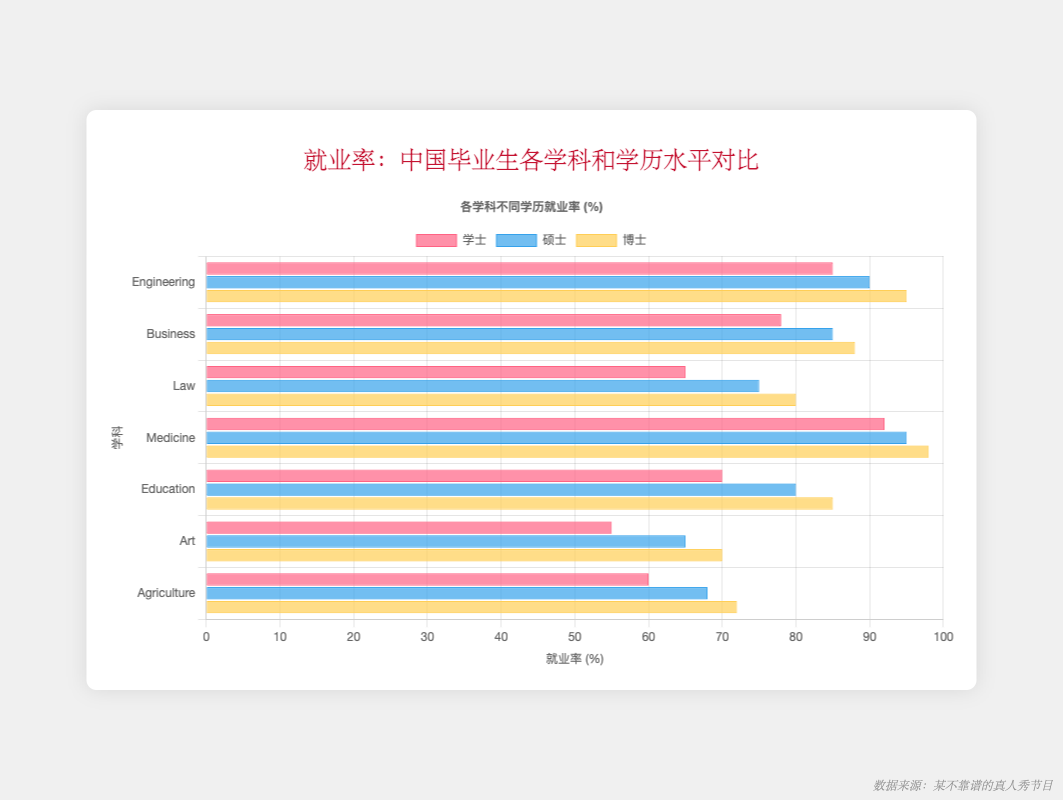What is the employment rate difference between PhD and Bachelor's degree holders in Engineering? To find the difference, look at the bar heights for Engineering for both PhD and Bachelor's education levels. For Engineering, the PhD employment rate is 95% and the Bachelor's rate is 85%. The difference is 95% - 85% = 10%.
Answer: 10% Which field has the highest employment rate at the PhD level? Identify the tallest bar within the PhD cluster across all fields. The field with the highest bar is Medicine with an employment rate of 98%.
Answer: Medicine Are the employment rates for Business graduates higher at the Master's level than at the Bachelor's level? Compare the heights of the bars labeled "Business" within the Bachelor's and Master's groups. The Master's bar is taller, indicating higher employment rates. Bachelor's for Business is 78% and Master's is 85%.
Answer: Yes How do the employment rates in Art differ between Bachelor's and Master's levels? Look at the bar heights for Art in both Bachelor and Master clusters. Bachelor's for Art is 55% and Master's is 65%. The difference is 65% - 55% = 10%.
Answer: 10% Which education level shows the most significant increase in employment rates for Law graduates? For Law, compare the differences between Bachelor's, Master's, and PhD employment rates. Bachelor's is 65%, Master's is 75%, and PhD is 80%. The most significant increase is from Bachelor to Master's: 75% - 65% = 10%.
Answer: Master's What is the combined employment rate of PhD graduates in Agriculture and Education fields? Add the employment rates for Agriculture and Education at the PhD level. Agriculture is 72% and Education is 85%. The combined rate is 72% + 85% = 157%.
Answer: 157% Is the employment rate for Medicine consistently the highest across all education levels? Compare the bar heights for Medicine across Bachelor's, Master's, and PhD levels with other fields. Medicine has consistently higher employment rates: Bachelor's is 92%, Master's is 95%, and PhD is 98%.
Answer: Yes Which color represents the Master's degree employment rates in the chart? Identify the color used for the Master's degree in the chart. Master's degree bars are colored blue.
Answer: Blue How much lower is the employment rate for Law graduates at the Bachelor's level compared to Medicine graduates at the same level? Compare the employment rates of Law and Medicine at the Bachelor's level. Law is 65% and Medicine is 92%. The difference is 92% - 65% = 27%.
Answer: 27% What is the average employment rate for Agriculture across all education levels? Calculate the average employment rate for Agriculture using Bachelor's, Master's, and PhD levels. Employment rates are 60% (Bachelor's), 68% (Master's), and 72% (PhD). Average = (60% + 68% + 72%) / 3 = 200% / 3 ≈ 66.67%.
Answer: 66.67% 